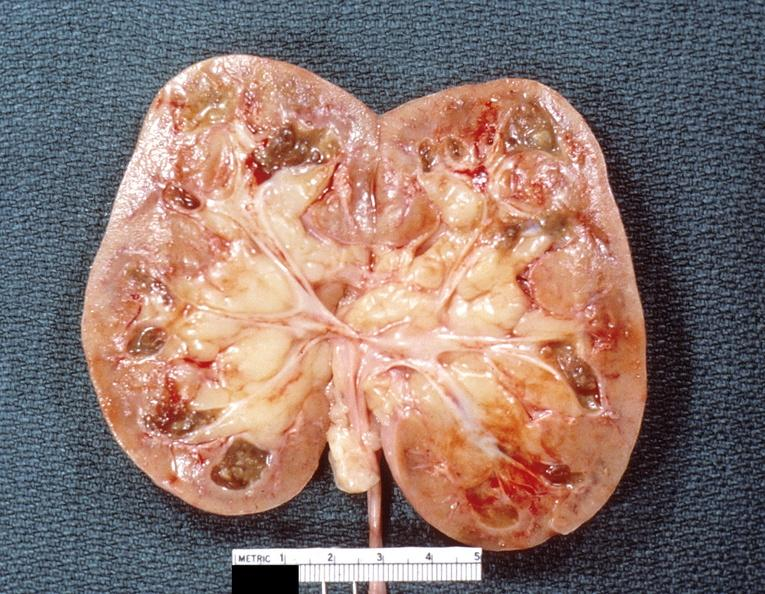what does this image show?
Answer the question using a single word or phrase. Kidney 